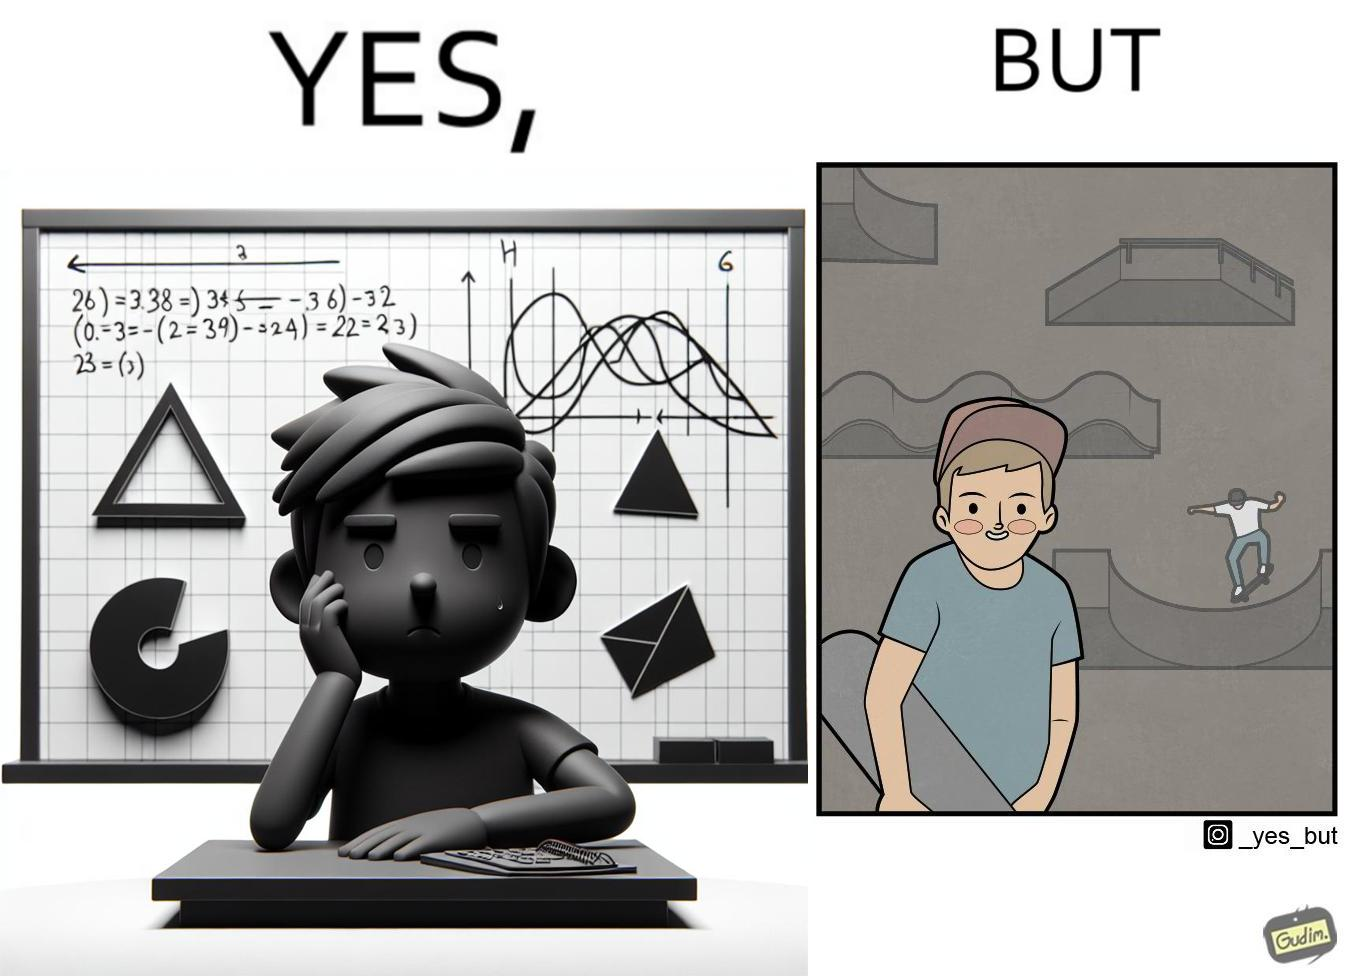Provide a description of this image. The image is ironical beaucse while the boy does not enjoy studying mathematics and different geometric shapes like semi circle and trapezoid and graphs of trigonometric equations like that of a sine wave, he enjoys skateboarding on surfaces and bowls that are built based on the said geometric shapes and graphs of trigonometric equations. 